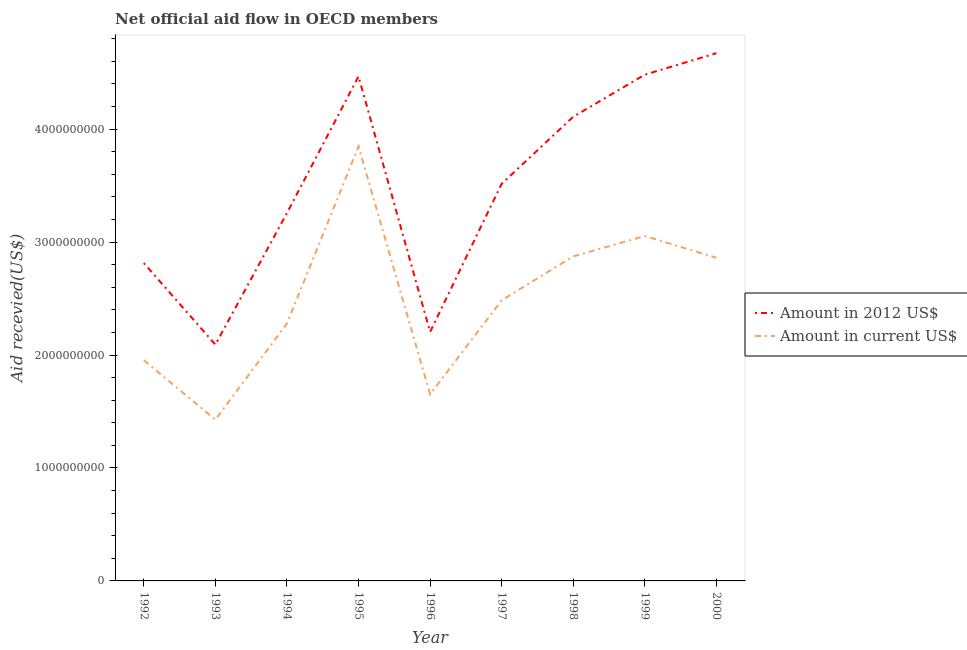How many different coloured lines are there?
Keep it short and to the point. 2. Does the line corresponding to amount of aid received(expressed in us$) intersect with the line corresponding to amount of aid received(expressed in 2012 us$)?
Ensure brevity in your answer.  No. What is the amount of aid received(expressed in 2012 us$) in 1998?
Your answer should be compact. 4.11e+09. Across all years, what is the maximum amount of aid received(expressed in 2012 us$)?
Provide a succinct answer. 4.67e+09. Across all years, what is the minimum amount of aid received(expressed in 2012 us$)?
Your answer should be very brief. 2.09e+09. What is the total amount of aid received(expressed in us$) in the graph?
Keep it short and to the point. 2.24e+1. What is the difference between the amount of aid received(expressed in 2012 us$) in 1998 and that in 2000?
Your answer should be compact. -5.63e+08. What is the difference between the amount of aid received(expressed in 2012 us$) in 1992 and the amount of aid received(expressed in us$) in 2000?
Provide a succinct answer. -4.72e+07. What is the average amount of aid received(expressed in 2012 us$) per year?
Provide a succinct answer. 3.51e+09. In the year 2000, what is the difference between the amount of aid received(expressed in us$) and amount of aid received(expressed in 2012 us$)?
Offer a very short reply. -1.81e+09. In how many years, is the amount of aid received(expressed in 2012 us$) greater than 4600000000 US$?
Your answer should be very brief. 1. What is the ratio of the amount of aid received(expressed in 2012 us$) in 1996 to that in 1998?
Make the answer very short. 0.54. What is the difference between the highest and the second highest amount of aid received(expressed in us$)?
Give a very brief answer. 7.93e+08. What is the difference between the highest and the lowest amount of aid received(expressed in 2012 us$)?
Offer a terse response. 2.58e+09. In how many years, is the amount of aid received(expressed in 2012 us$) greater than the average amount of aid received(expressed in 2012 us$) taken over all years?
Your response must be concise. 5. Is the sum of the amount of aid received(expressed in us$) in 1992 and 1999 greater than the maximum amount of aid received(expressed in 2012 us$) across all years?
Your answer should be compact. Yes. Is the amount of aid received(expressed in us$) strictly greater than the amount of aid received(expressed in 2012 us$) over the years?
Keep it short and to the point. No. How many lines are there?
Offer a very short reply. 2. How many years are there in the graph?
Give a very brief answer. 9. What is the difference between two consecutive major ticks on the Y-axis?
Make the answer very short. 1.00e+09. Are the values on the major ticks of Y-axis written in scientific E-notation?
Give a very brief answer. No. Does the graph contain any zero values?
Offer a terse response. No. Does the graph contain grids?
Give a very brief answer. No. Where does the legend appear in the graph?
Offer a very short reply. Center right. How are the legend labels stacked?
Your answer should be compact. Vertical. What is the title of the graph?
Ensure brevity in your answer.  Net official aid flow in OECD members. Does "Technicians" appear as one of the legend labels in the graph?
Give a very brief answer. No. What is the label or title of the Y-axis?
Make the answer very short. Aid recevied(US$). What is the Aid recevied(US$) in Amount in 2012 US$ in 1992?
Ensure brevity in your answer.  2.81e+09. What is the Aid recevied(US$) of Amount in current US$ in 1992?
Your answer should be compact. 1.95e+09. What is the Aid recevied(US$) of Amount in 2012 US$ in 1993?
Provide a succinct answer. 2.09e+09. What is the Aid recevied(US$) of Amount in current US$ in 1993?
Keep it short and to the point. 1.43e+09. What is the Aid recevied(US$) in Amount in 2012 US$ in 1994?
Offer a very short reply. 3.26e+09. What is the Aid recevied(US$) in Amount in current US$ in 1994?
Your response must be concise. 2.28e+09. What is the Aid recevied(US$) in Amount in 2012 US$ in 1995?
Offer a terse response. 4.47e+09. What is the Aid recevied(US$) of Amount in current US$ in 1995?
Ensure brevity in your answer.  3.85e+09. What is the Aid recevied(US$) in Amount in 2012 US$ in 1996?
Your answer should be compact. 2.20e+09. What is the Aid recevied(US$) of Amount in current US$ in 1996?
Offer a very short reply. 1.65e+09. What is the Aid recevied(US$) of Amount in 2012 US$ in 1997?
Keep it short and to the point. 3.52e+09. What is the Aid recevied(US$) in Amount in current US$ in 1997?
Provide a short and direct response. 2.48e+09. What is the Aid recevied(US$) in Amount in 2012 US$ in 1998?
Your answer should be very brief. 4.11e+09. What is the Aid recevied(US$) of Amount in current US$ in 1998?
Provide a short and direct response. 2.87e+09. What is the Aid recevied(US$) of Amount in 2012 US$ in 1999?
Provide a succinct answer. 4.48e+09. What is the Aid recevied(US$) of Amount in current US$ in 1999?
Provide a short and direct response. 3.05e+09. What is the Aid recevied(US$) of Amount in 2012 US$ in 2000?
Provide a short and direct response. 4.67e+09. What is the Aid recevied(US$) in Amount in current US$ in 2000?
Offer a very short reply. 2.86e+09. Across all years, what is the maximum Aid recevied(US$) of Amount in 2012 US$?
Your response must be concise. 4.67e+09. Across all years, what is the maximum Aid recevied(US$) of Amount in current US$?
Your response must be concise. 3.85e+09. Across all years, what is the minimum Aid recevied(US$) of Amount in 2012 US$?
Your answer should be compact. 2.09e+09. Across all years, what is the minimum Aid recevied(US$) of Amount in current US$?
Make the answer very short. 1.43e+09. What is the total Aid recevied(US$) in Amount in 2012 US$ in the graph?
Keep it short and to the point. 3.16e+1. What is the total Aid recevied(US$) in Amount in current US$ in the graph?
Make the answer very short. 2.24e+1. What is the difference between the Aid recevied(US$) in Amount in 2012 US$ in 1992 and that in 1993?
Provide a succinct answer. 7.22e+08. What is the difference between the Aid recevied(US$) of Amount in current US$ in 1992 and that in 1993?
Your answer should be very brief. 5.26e+08. What is the difference between the Aid recevied(US$) of Amount in 2012 US$ in 1992 and that in 1994?
Offer a very short reply. -4.43e+08. What is the difference between the Aid recevied(US$) in Amount in current US$ in 1992 and that in 1994?
Give a very brief answer. -3.25e+08. What is the difference between the Aid recevied(US$) in Amount in 2012 US$ in 1992 and that in 1995?
Provide a succinct answer. -1.65e+09. What is the difference between the Aid recevied(US$) in Amount in current US$ in 1992 and that in 1995?
Make the answer very short. -1.89e+09. What is the difference between the Aid recevied(US$) in Amount in 2012 US$ in 1992 and that in 1996?
Make the answer very short. 6.09e+08. What is the difference between the Aid recevied(US$) in Amount in current US$ in 1992 and that in 1996?
Your response must be concise. 3.02e+08. What is the difference between the Aid recevied(US$) of Amount in 2012 US$ in 1992 and that in 1997?
Your answer should be compact. -7.02e+08. What is the difference between the Aid recevied(US$) in Amount in current US$ in 1992 and that in 1997?
Keep it short and to the point. -5.30e+08. What is the difference between the Aid recevied(US$) in Amount in 2012 US$ in 1992 and that in 1998?
Ensure brevity in your answer.  -1.30e+09. What is the difference between the Aid recevied(US$) in Amount in current US$ in 1992 and that in 1998?
Give a very brief answer. -9.20e+08. What is the difference between the Aid recevied(US$) in Amount in 2012 US$ in 1992 and that in 1999?
Your answer should be very brief. -1.67e+09. What is the difference between the Aid recevied(US$) of Amount in current US$ in 1992 and that in 1999?
Offer a terse response. -1.10e+09. What is the difference between the Aid recevied(US$) of Amount in 2012 US$ in 1992 and that in 2000?
Make the answer very short. -1.86e+09. What is the difference between the Aid recevied(US$) in Amount in current US$ in 1992 and that in 2000?
Provide a short and direct response. -9.07e+08. What is the difference between the Aid recevied(US$) of Amount in 2012 US$ in 1993 and that in 1994?
Your answer should be compact. -1.16e+09. What is the difference between the Aid recevied(US$) in Amount in current US$ in 1993 and that in 1994?
Make the answer very short. -8.51e+08. What is the difference between the Aid recevied(US$) of Amount in 2012 US$ in 1993 and that in 1995?
Offer a terse response. -2.37e+09. What is the difference between the Aid recevied(US$) in Amount in current US$ in 1993 and that in 1995?
Your response must be concise. -2.42e+09. What is the difference between the Aid recevied(US$) of Amount in 2012 US$ in 1993 and that in 1996?
Your answer should be compact. -1.12e+08. What is the difference between the Aid recevied(US$) in Amount in current US$ in 1993 and that in 1996?
Offer a terse response. -2.25e+08. What is the difference between the Aid recevied(US$) of Amount in 2012 US$ in 1993 and that in 1997?
Give a very brief answer. -1.42e+09. What is the difference between the Aid recevied(US$) in Amount in current US$ in 1993 and that in 1997?
Offer a terse response. -1.06e+09. What is the difference between the Aid recevied(US$) of Amount in 2012 US$ in 1993 and that in 1998?
Provide a succinct answer. -2.02e+09. What is the difference between the Aid recevied(US$) of Amount in current US$ in 1993 and that in 1998?
Keep it short and to the point. -1.45e+09. What is the difference between the Aid recevied(US$) of Amount in 2012 US$ in 1993 and that in 1999?
Your answer should be compact. -2.39e+09. What is the difference between the Aid recevied(US$) in Amount in current US$ in 1993 and that in 1999?
Make the answer very short. -1.63e+09. What is the difference between the Aid recevied(US$) of Amount in 2012 US$ in 1993 and that in 2000?
Offer a terse response. -2.58e+09. What is the difference between the Aid recevied(US$) in Amount in current US$ in 1993 and that in 2000?
Keep it short and to the point. -1.43e+09. What is the difference between the Aid recevied(US$) in Amount in 2012 US$ in 1994 and that in 1995?
Keep it short and to the point. -1.21e+09. What is the difference between the Aid recevied(US$) of Amount in current US$ in 1994 and that in 1995?
Keep it short and to the point. -1.57e+09. What is the difference between the Aid recevied(US$) of Amount in 2012 US$ in 1994 and that in 1996?
Provide a succinct answer. 1.05e+09. What is the difference between the Aid recevied(US$) of Amount in current US$ in 1994 and that in 1996?
Ensure brevity in your answer.  6.26e+08. What is the difference between the Aid recevied(US$) in Amount in 2012 US$ in 1994 and that in 1997?
Your response must be concise. -2.59e+08. What is the difference between the Aid recevied(US$) in Amount in current US$ in 1994 and that in 1997?
Provide a succinct answer. -2.05e+08. What is the difference between the Aid recevied(US$) in Amount in 2012 US$ in 1994 and that in 1998?
Offer a very short reply. -8.53e+08. What is the difference between the Aid recevied(US$) of Amount in current US$ in 1994 and that in 1998?
Ensure brevity in your answer.  -5.95e+08. What is the difference between the Aid recevied(US$) in Amount in 2012 US$ in 1994 and that in 1999?
Your response must be concise. -1.23e+09. What is the difference between the Aid recevied(US$) of Amount in current US$ in 1994 and that in 1999?
Offer a terse response. -7.75e+08. What is the difference between the Aid recevied(US$) in Amount in 2012 US$ in 1994 and that in 2000?
Provide a short and direct response. -1.42e+09. What is the difference between the Aid recevied(US$) of Amount in current US$ in 1994 and that in 2000?
Your answer should be very brief. -5.83e+08. What is the difference between the Aid recevied(US$) in Amount in 2012 US$ in 1995 and that in 1996?
Provide a succinct answer. 2.26e+09. What is the difference between the Aid recevied(US$) of Amount in current US$ in 1995 and that in 1996?
Offer a terse response. 2.19e+09. What is the difference between the Aid recevied(US$) of Amount in 2012 US$ in 1995 and that in 1997?
Provide a short and direct response. 9.51e+08. What is the difference between the Aid recevied(US$) of Amount in current US$ in 1995 and that in 1997?
Make the answer very short. 1.36e+09. What is the difference between the Aid recevied(US$) of Amount in 2012 US$ in 1995 and that in 1998?
Give a very brief answer. 3.58e+08. What is the difference between the Aid recevied(US$) in Amount in current US$ in 1995 and that in 1998?
Your answer should be very brief. 9.73e+08. What is the difference between the Aid recevied(US$) of Amount in 2012 US$ in 1995 and that in 1999?
Your answer should be very brief. -1.53e+07. What is the difference between the Aid recevied(US$) of Amount in current US$ in 1995 and that in 1999?
Make the answer very short. 7.93e+08. What is the difference between the Aid recevied(US$) of Amount in 2012 US$ in 1995 and that in 2000?
Provide a succinct answer. -2.05e+08. What is the difference between the Aid recevied(US$) of Amount in current US$ in 1995 and that in 2000?
Provide a succinct answer. 9.85e+08. What is the difference between the Aid recevied(US$) of Amount in 2012 US$ in 1996 and that in 1997?
Provide a succinct answer. -1.31e+09. What is the difference between the Aid recevied(US$) of Amount in current US$ in 1996 and that in 1997?
Ensure brevity in your answer.  -8.32e+08. What is the difference between the Aid recevied(US$) in Amount in 2012 US$ in 1996 and that in 1998?
Your answer should be compact. -1.90e+09. What is the difference between the Aid recevied(US$) of Amount in current US$ in 1996 and that in 1998?
Your answer should be very brief. -1.22e+09. What is the difference between the Aid recevied(US$) of Amount in 2012 US$ in 1996 and that in 1999?
Provide a succinct answer. -2.28e+09. What is the difference between the Aid recevied(US$) in Amount in current US$ in 1996 and that in 1999?
Offer a very short reply. -1.40e+09. What is the difference between the Aid recevied(US$) of Amount in 2012 US$ in 1996 and that in 2000?
Offer a terse response. -2.47e+09. What is the difference between the Aid recevied(US$) in Amount in current US$ in 1996 and that in 2000?
Your answer should be compact. -1.21e+09. What is the difference between the Aid recevied(US$) of Amount in 2012 US$ in 1997 and that in 1998?
Provide a short and direct response. -5.93e+08. What is the difference between the Aid recevied(US$) in Amount in current US$ in 1997 and that in 1998?
Make the answer very short. -3.89e+08. What is the difference between the Aid recevied(US$) of Amount in 2012 US$ in 1997 and that in 1999?
Make the answer very short. -9.66e+08. What is the difference between the Aid recevied(US$) of Amount in current US$ in 1997 and that in 1999?
Your answer should be compact. -5.70e+08. What is the difference between the Aid recevied(US$) of Amount in 2012 US$ in 1997 and that in 2000?
Offer a very short reply. -1.16e+09. What is the difference between the Aid recevied(US$) in Amount in current US$ in 1997 and that in 2000?
Your answer should be compact. -3.77e+08. What is the difference between the Aid recevied(US$) in Amount in 2012 US$ in 1998 and that in 1999?
Offer a very short reply. -3.73e+08. What is the difference between the Aid recevied(US$) in Amount in current US$ in 1998 and that in 1999?
Make the answer very short. -1.80e+08. What is the difference between the Aid recevied(US$) in Amount in 2012 US$ in 1998 and that in 2000?
Keep it short and to the point. -5.63e+08. What is the difference between the Aid recevied(US$) in Amount in current US$ in 1998 and that in 2000?
Offer a terse response. 1.22e+07. What is the difference between the Aid recevied(US$) of Amount in 2012 US$ in 1999 and that in 2000?
Your response must be concise. -1.90e+08. What is the difference between the Aid recevied(US$) in Amount in current US$ in 1999 and that in 2000?
Your response must be concise. 1.92e+08. What is the difference between the Aid recevied(US$) of Amount in 2012 US$ in 1992 and the Aid recevied(US$) of Amount in current US$ in 1993?
Make the answer very short. 1.39e+09. What is the difference between the Aid recevied(US$) of Amount in 2012 US$ in 1992 and the Aid recevied(US$) of Amount in current US$ in 1994?
Offer a terse response. 5.35e+08. What is the difference between the Aid recevied(US$) in Amount in 2012 US$ in 1992 and the Aid recevied(US$) in Amount in current US$ in 1995?
Provide a succinct answer. -1.03e+09. What is the difference between the Aid recevied(US$) of Amount in 2012 US$ in 1992 and the Aid recevied(US$) of Amount in current US$ in 1996?
Your answer should be compact. 1.16e+09. What is the difference between the Aid recevied(US$) in Amount in 2012 US$ in 1992 and the Aid recevied(US$) in Amount in current US$ in 1997?
Your response must be concise. 3.30e+08. What is the difference between the Aid recevied(US$) of Amount in 2012 US$ in 1992 and the Aid recevied(US$) of Amount in current US$ in 1998?
Your answer should be compact. -5.94e+07. What is the difference between the Aid recevied(US$) of Amount in 2012 US$ in 1992 and the Aid recevied(US$) of Amount in current US$ in 1999?
Ensure brevity in your answer.  -2.40e+08. What is the difference between the Aid recevied(US$) in Amount in 2012 US$ in 1992 and the Aid recevied(US$) in Amount in current US$ in 2000?
Keep it short and to the point. -4.72e+07. What is the difference between the Aid recevied(US$) in Amount in 2012 US$ in 1993 and the Aid recevied(US$) in Amount in current US$ in 1994?
Make the answer very short. -1.87e+08. What is the difference between the Aid recevied(US$) in Amount in 2012 US$ in 1993 and the Aid recevied(US$) in Amount in current US$ in 1995?
Give a very brief answer. -1.75e+09. What is the difference between the Aid recevied(US$) of Amount in 2012 US$ in 1993 and the Aid recevied(US$) of Amount in current US$ in 1996?
Keep it short and to the point. 4.40e+08. What is the difference between the Aid recevied(US$) in Amount in 2012 US$ in 1993 and the Aid recevied(US$) in Amount in current US$ in 1997?
Your answer should be very brief. -3.92e+08. What is the difference between the Aid recevied(US$) of Amount in 2012 US$ in 1993 and the Aid recevied(US$) of Amount in current US$ in 1998?
Provide a succinct answer. -7.81e+08. What is the difference between the Aid recevied(US$) in Amount in 2012 US$ in 1993 and the Aid recevied(US$) in Amount in current US$ in 1999?
Provide a short and direct response. -9.62e+08. What is the difference between the Aid recevied(US$) in Amount in 2012 US$ in 1993 and the Aid recevied(US$) in Amount in current US$ in 2000?
Offer a very short reply. -7.69e+08. What is the difference between the Aid recevied(US$) of Amount in 2012 US$ in 1994 and the Aid recevied(US$) of Amount in current US$ in 1995?
Keep it short and to the point. -5.90e+08. What is the difference between the Aid recevied(US$) of Amount in 2012 US$ in 1994 and the Aid recevied(US$) of Amount in current US$ in 1996?
Make the answer very short. 1.60e+09. What is the difference between the Aid recevied(US$) of Amount in 2012 US$ in 1994 and the Aid recevied(US$) of Amount in current US$ in 1997?
Keep it short and to the point. 7.72e+08. What is the difference between the Aid recevied(US$) in Amount in 2012 US$ in 1994 and the Aid recevied(US$) in Amount in current US$ in 1998?
Ensure brevity in your answer.  3.83e+08. What is the difference between the Aid recevied(US$) in Amount in 2012 US$ in 1994 and the Aid recevied(US$) in Amount in current US$ in 1999?
Your answer should be compact. 2.03e+08. What is the difference between the Aid recevied(US$) in Amount in 2012 US$ in 1994 and the Aid recevied(US$) in Amount in current US$ in 2000?
Provide a short and direct response. 3.95e+08. What is the difference between the Aid recevied(US$) of Amount in 2012 US$ in 1995 and the Aid recevied(US$) of Amount in current US$ in 1996?
Make the answer very short. 2.81e+09. What is the difference between the Aid recevied(US$) in Amount in 2012 US$ in 1995 and the Aid recevied(US$) in Amount in current US$ in 1997?
Keep it short and to the point. 1.98e+09. What is the difference between the Aid recevied(US$) of Amount in 2012 US$ in 1995 and the Aid recevied(US$) of Amount in current US$ in 1998?
Offer a terse response. 1.59e+09. What is the difference between the Aid recevied(US$) in Amount in 2012 US$ in 1995 and the Aid recevied(US$) in Amount in current US$ in 1999?
Provide a short and direct response. 1.41e+09. What is the difference between the Aid recevied(US$) in Amount in 2012 US$ in 1995 and the Aid recevied(US$) in Amount in current US$ in 2000?
Give a very brief answer. 1.61e+09. What is the difference between the Aid recevied(US$) of Amount in 2012 US$ in 1996 and the Aid recevied(US$) of Amount in current US$ in 1997?
Your answer should be compact. -2.80e+08. What is the difference between the Aid recevied(US$) in Amount in 2012 US$ in 1996 and the Aid recevied(US$) in Amount in current US$ in 1998?
Your answer should be compact. -6.69e+08. What is the difference between the Aid recevied(US$) in Amount in 2012 US$ in 1996 and the Aid recevied(US$) in Amount in current US$ in 1999?
Give a very brief answer. -8.49e+08. What is the difference between the Aid recevied(US$) of Amount in 2012 US$ in 1996 and the Aid recevied(US$) of Amount in current US$ in 2000?
Your answer should be very brief. -6.57e+08. What is the difference between the Aid recevied(US$) in Amount in 2012 US$ in 1997 and the Aid recevied(US$) in Amount in current US$ in 1998?
Ensure brevity in your answer.  6.43e+08. What is the difference between the Aid recevied(US$) of Amount in 2012 US$ in 1997 and the Aid recevied(US$) of Amount in current US$ in 1999?
Provide a succinct answer. 4.62e+08. What is the difference between the Aid recevied(US$) of Amount in 2012 US$ in 1997 and the Aid recevied(US$) of Amount in current US$ in 2000?
Keep it short and to the point. 6.55e+08. What is the difference between the Aid recevied(US$) in Amount in 2012 US$ in 1998 and the Aid recevied(US$) in Amount in current US$ in 1999?
Your answer should be compact. 1.06e+09. What is the difference between the Aid recevied(US$) of Amount in 2012 US$ in 1998 and the Aid recevied(US$) of Amount in current US$ in 2000?
Ensure brevity in your answer.  1.25e+09. What is the difference between the Aid recevied(US$) in Amount in 2012 US$ in 1999 and the Aid recevied(US$) in Amount in current US$ in 2000?
Provide a succinct answer. 1.62e+09. What is the average Aid recevied(US$) in Amount in 2012 US$ per year?
Offer a terse response. 3.51e+09. What is the average Aid recevied(US$) in Amount in current US$ per year?
Your answer should be compact. 2.49e+09. In the year 1992, what is the difference between the Aid recevied(US$) in Amount in 2012 US$ and Aid recevied(US$) in Amount in current US$?
Provide a short and direct response. 8.60e+08. In the year 1993, what is the difference between the Aid recevied(US$) in Amount in 2012 US$ and Aid recevied(US$) in Amount in current US$?
Provide a short and direct response. 6.65e+08. In the year 1994, what is the difference between the Aid recevied(US$) in Amount in 2012 US$ and Aid recevied(US$) in Amount in current US$?
Give a very brief answer. 9.78e+08. In the year 1995, what is the difference between the Aid recevied(US$) of Amount in 2012 US$ and Aid recevied(US$) of Amount in current US$?
Provide a short and direct response. 6.20e+08. In the year 1996, what is the difference between the Aid recevied(US$) in Amount in 2012 US$ and Aid recevied(US$) in Amount in current US$?
Give a very brief answer. 5.52e+08. In the year 1997, what is the difference between the Aid recevied(US$) in Amount in 2012 US$ and Aid recevied(US$) in Amount in current US$?
Provide a short and direct response. 1.03e+09. In the year 1998, what is the difference between the Aid recevied(US$) of Amount in 2012 US$ and Aid recevied(US$) of Amount in current US$?
Ensure brevity in your answer.  1.24e+09. In the year 1999, what is the difference between the Aid recevied(US$) of Amount in 2012 US$ and Aid recevied(US$) of Amount in current US$?
Ensure brevity in your answer.  1.43e+09. In the year 2000, what is the difference between the Aid recevied(US$) in Amount in 2012 US$ and Aid recevied(US$) in Amount in current US$?
Offer a very short reply. 1.81e+09. What is the ratio of the Aid recevied(US$) of Amount in 2012 US$ in 1992 to that in 1993?
Your answer should be compact. 1.34. What is the ratio of the Aid recevied(US$) of Amount in current US$ in 1992 to that in 1993?
Keep it short and to the point. 1.37. What is the ratio of the Aid recevied(US$) of Amount in 2012 US$ in 1992 to that in 1994?
Ensure brevity in your answer.  0.86. What is the ratio of the Aid recevied(US$) of Amount in current US$ in 1992 to that in 1994?
Provide a short and direct response. 0.86. What is the ratio of the Aid recevied(US$) of Amount in 2012 US$ in 1992 to that in 1995?
Offer a terse response. 0.63. What is the ratio of the Aid recevied(US$) in Amount in current US$ in 1992 to that in 1995?
Keep it short and to the point. 0.51. What is the ratio of the Aid recevied(US$) in Amount in 2012 US$ in 1992 to that in 1996?
Make the answer very short. 1.28. What is the ratio of the Aid recevied(US$) of Amount in current US$ in 1992 to that in 1996?
Your response must be concise. 1.18. What is the ratio of the Aid recevied(US$) of Amount in 2012 US$ in 1992 to that in 1997?
Offer a very short reply. 0.8. What is the ratio of the Aid recevied(US$) of Amount in current US$ in 1992 to that in 1997?
Ensure brevity in your answer.  0.79. What is the ratio of the Aid recevied(US$) in Amount in 2012 US$ in 1992 to that in 1998?
Ensure brevity in your answer.  0.68. What is the ratio of the Aid recevied(US$) in Amount in current US$ in 1992 to that in 1998?
Give a very brief answer. 0.68. What is the ratio of the Aid recevied(US$) in Amount in 2012 US$ in 1992 to that in 1999?
Provide a succinct answer. 0.63. What is the ratio of the Aid recevied(US$) in Amount in current US$ in 1992 to that in 1999?
Offer a terse response. 0.64. What is the ratio of the Aid recevied(US$) of Amount in 2012 US$ in 1992 to that in 2000?
Give a very brief answer. 0.6. What is the ratio of the Aid recevied(US$) in Amount in current US$ in 1992 to that in 2000?
Ensure brevity in your answer.  0.68. What is the ratio of the Aid recevied(US$) of Amount in 2012 US$ in 1993 to that in 1994?
Offer a very short reply. 0.64. What is the ratio of the Aid recevied(US$) of Amount in current US$ in 1993 to that in 1994?
Offer a very short reply. 0.63. What is the ratio of the Aid recevied(US$) in Amount in 2012 US$ in 1993 to that in 1995?
Offer a very short reply. 0.47. What is the ratio of the Aid recevied(US$) in Amount in current US$ in 1993 to that in 1995?
Make the answer very short. 0.37. What is the ratio of the Aid recevied(US$) of Amount in 2012 US$ in 1993 to that in 1996?
Offer a very short reply. 0.95. What is the ratio of the Aid recevied(US$) of Amount in current US$ in 1993 to that in 1996?
Provide a short and direct response. 0.86. What is the ratio of the Aid recevied(US$) of Amount in 2012 US$ in 1993 to that in 1997?
Ensure brevity in your answer.  0.6. What is the ratio of the Aid recevied(US$) in Amount in current US$ in 1993 to that in 1997?
Give a very brief answer. 0.57. What is the ratio of the Aid recevied(US$) in Amount in 2012 US$ in 1993 to that in 1998?
Your response must be concise. 0.51. What is the ratio of the Aid recevied(US$) of Amount in current US$ in 1993 to that in 1998?
Your answer should be compact. 0.5. What is the ratio of the Aid recevied(US$) in Amount in 2012 US$ in 1993 to that in 1999?
Provide a short and direct response. 0.47. What is the ratio of the Aid recevied(US$) in Amount in current US$ in 1993 to that in 1999?
Provide a short and direct response. 0.47. What is the ratio of the Aid recevied(US$) in Amount in 2012 US$ in 1993 to that in 2000?
Ensure brevity in your answer.  0.45. What is the ratio of the Aid recevied(US$) of Amount in current US$ in 1993 to that in 2000?
Your answer should be compact. 0.5. What is the ratio of the Aid recevied(US$) in Amount in 2012 US$ in 1994 to that in 1995?
Make the answer very short. 0.73. What is the ratio of the Aid recevied(US$) in Amount in current US$ in 1994 to that in 1995?
Offer a very short reply. 0.59. What is the ratio of the Aid recevied(US$) of Amount in 2012 US$ in 1994 to that in 1996?
Ensure brevity in your answer.  1.48. What is the ratio of the Aid recevied(US$) in Amount in current US$ in 1994 to that in 1996?
Provide a short and direct response. 1.38. What is the ratio of the Aid recevied(US$) of Amount in 2012 US$ in 1994 to that in 1997?
Keep it short and to the point. 0.93. What is the ratio of the Aid recevied(US$) of Amount in current US$ in 1994 to that in 1997?
Provide a short and direct response. 0.92. What is the ratio of the Aid recevied(US$) of Amount in 2012 US$ in 1994 to that in 1998?
Provide a succinct answer. 0.79. What is the ratio of the Aid recevied(US$) in Amount in current US$ in 1994 to that in 1998?
Offer a terse response. 0.79. What is the ratio of the Aid recevied(US$) in Amount in 2012 US$ in 1994 to that in 1999?
Your answer should be very brief. 0.73. What is the ratio of the Aid recevied(US$) in Amount in current US$ in 1994 to that in 1999?
Your answer should be very brief. 0.75. What is the ratio of the Aid recevied(US$) of Amount in 2012 US$ in 1994 to that in 2000?
Offer a terse response. 0.7. What is the ratio of the Aid recevied(US$) of Amount in current US$ in 1994 to that in 2000?
Keep it short and to the point. 0.8. What is the ratio of the Aid recevied(US$) of Amount in 2012 US$ in 1995 to that in 1996?
Ensure brevity in your answer.  2.03. What is the ratio of the Aid recevied(US$) in Amount in current US$ in 1995 to that in 1996?
Offer a terse response. 2.33. What is the ratio of the Aid recevied(US$) of Amount in 2012 US$ in 1995 to that in 1997?
Keep it short and to the point. 1.27. What is the ratio of the Aid recevied(US$) in Amount in current US$ in 1995 to that in 1997?
Give a very brief answer. 1.55. What is the ratio of the Aid recevied(US$) of Amount in 2012 US$ in 1995 to that in 1998?
Offer a very short reply. 1.09. What is the ratio of the Aid recevied(US$) of Amount in current US$ in 1995 to that in 1998?
Ensure brevity in your answer.  1.34. What is the ratio of the Aid recevied(US$) in Amount in current US$ in 1995 to that in 1999?
Give a very brief answer. 1.26. What is the ratio of the Aid recevied(US$) of Amount in 2012 US$ in 1995 to that in 2000?
Offer a terse response. 0.96. What is the ratio of the Aid recevied(US$) of Amount in current US$ in 1995 to that in 2000?
Your answer should be compact. 1.34. What is the ratio of the Aid recevied(US$) in Amount in 2012 US$ in 1996 to that in 1997?
Your answer should be compact. 0.63. What is the ratio of the Aid recevied(US$) in Amount in current US$ in 1996 to that in 1997?
Make the answer very short. 0.67. What is the ratio of the Aid recevied(US$) in Amount in 2012 US$ in 1996 to that in 1998?
Provide a succinct answer. 0.54. What is the ratio of the Aid recevied(US$) in Amount in current US$ in 1996 to that in 1998?
Keep it short and to the point. 0.58. What is the ratio of the Aid recevied(US$) in Amount in 2012 US$ in 1996 to that in 1999?
Keep it short and to the point. 0.49. What is the ratio of the Aid recevied(US$) of Amount in current US$ in 1996 to that in 1999?
Make the answer very short. 0.54. What is the ratio of the Aid recevied(US$) in Amount in 2012 US$ in 1996 to that in 2000?
Provide a succinct answer. 0.47. What is the ratio of the Aid recevied(US$) of Amount in current US$ in 1996 to that in 2000?
Offer a very short reply. 0.58. What is the ratio of the Aid recevied(US$) in Amount in 2012 US$ in 1997 to that in 1998?
Your response must be concise. 0.86. What is the ratio of the Aid recevied(US$) of Amount in current US$ in 1997 to that in 1998?
Give a very brief answer. 0.86. What is the ratio of the Aid recevied(US$) in Amount in 2012 US$ in 1997 to that in 1999?
Your answer should be compact. 0.78. What is the ratio of the Aid recevied(US$) in Amount in current US$ in 1997 to that in 1999?
Keep it short and to the point. 0.81. What is the ratio of the Aid recevied(US$) of Amount in 2012 US$ in 1997 to that in 2000?
Make the answer very short. 0.75. What is the ratio of the Aid recevied(US$) in Amount in current US$ in 1997 to that in 2000?
Your answer should be very brief. 0.87. What is the ratio of the Aid recevied(US$) of Amount in 2012 US$ in 1998 to that in 1999?
Keep it short and to the point. 0.92. What is the ratio of the Aid recevied(US$) in Amount in current US$ in 1998 to that in 1999?
Ensure brevity in your answer.  0.94. What is the ratio of the Aid recevied(US$) in Amount in 2012 US$ in 1998 to that in 2000?
Provide a succinct answer. 0.88. What is the ratio of the Aid recevied(US$) of Amount in 2012 US$ in 1999 to that in 2000?
Offer a very short reply. 0.96. What is the ratio of the Aid recevied(US$) in Amount in current US$ in 1999 to that in 2000?
Your response must be concise. 1.07. What is the difference between the highest and the second highest Aid recevied(US$) in Amount in 2012 US$?
Your answer should be compact. 1.90e+08. What is the difference between the highest and the second highest Aid recevied(US$) of Amount in current US$?
Provide a succinct answer. 7.93e+08. What is the difference between the highest and the lowest Aid recevied(US$) of Amount in 2012 US$?
Offer a very short reply. 2.58e+09. What is the difference between the highest and the lowest Aid recevied(US$) in Amount in current US$?
Make the answer very short. 2.42e+09. 